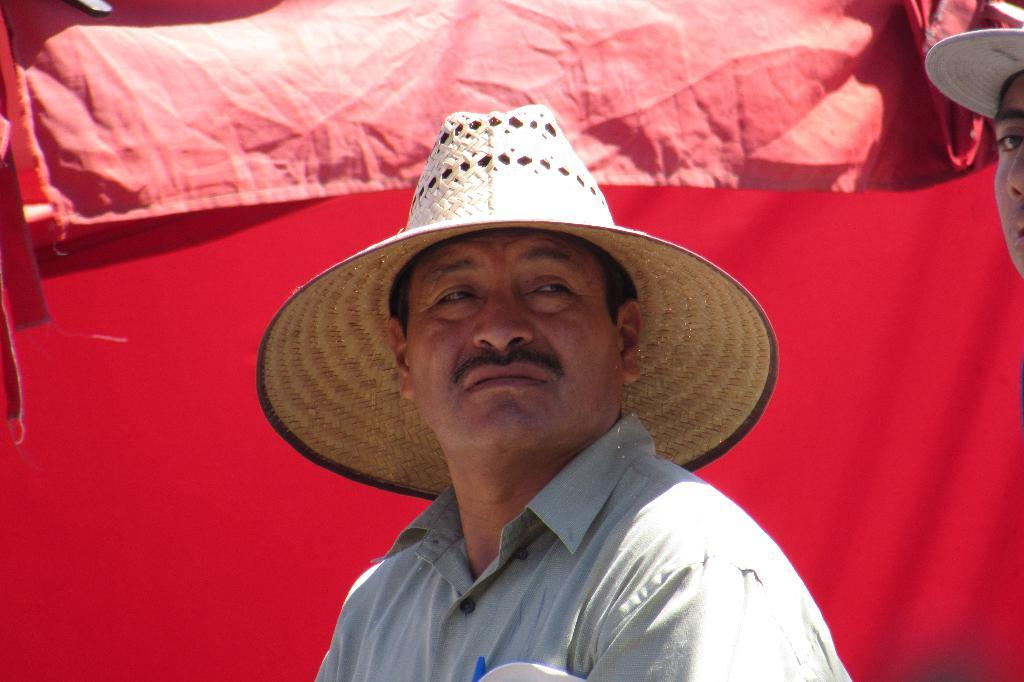How many people are in the image? There are two persons in the image. What are the persons wearing on their heads? Both persons are wearing hats. What color is the background of the image? The background of the image is red. How many balls are visible in the image? There are no balls present in the image. What type of spiders can be seen crawling on the persons' hats? There are no spiders present in the image; the persons are wearing hats, but there is no mention of spiders. 